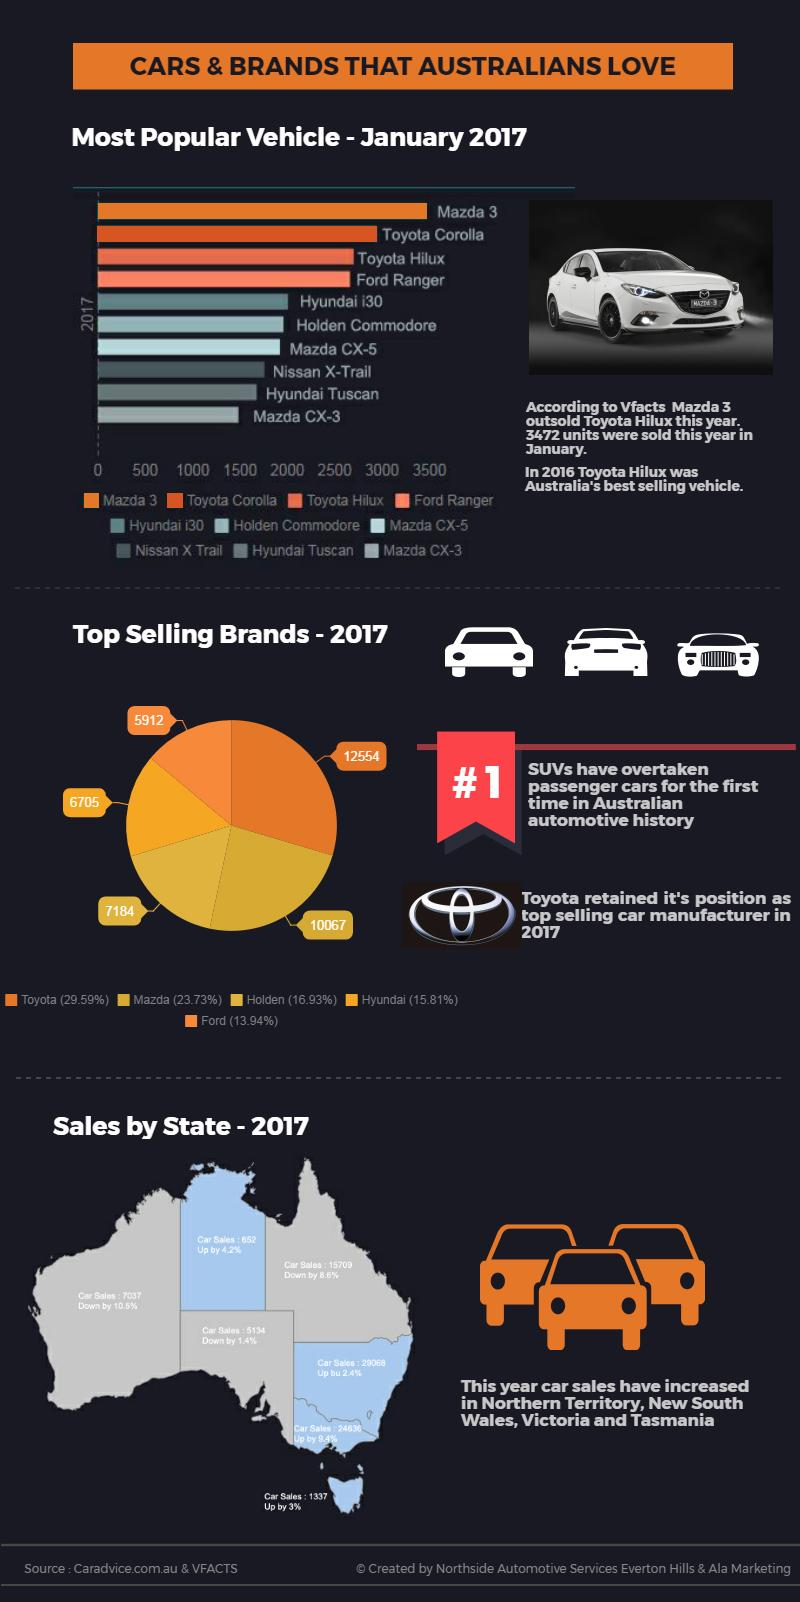Point out several critical features in this image. In 2017, a total of 7,184 Holden cars were sold in Australia. The region of Australia shown in blue color in the south east is named Victoria. Hyundai i30 is the fifth most popular car brand among famous brands in Australia. The percentage difference in car sales between New South Wales and Victoria is 7%. In 2017, a total of 6,705 Hyundai cars were sold in Australia. 